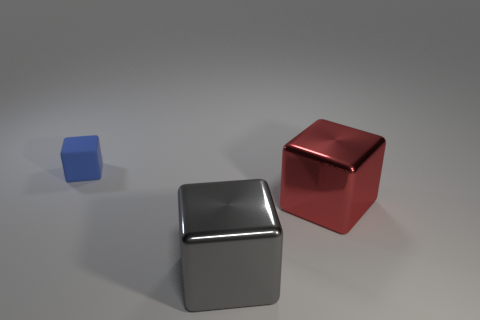What is the color of the other shiny thing that is the same shape as the big gray metal object? red 